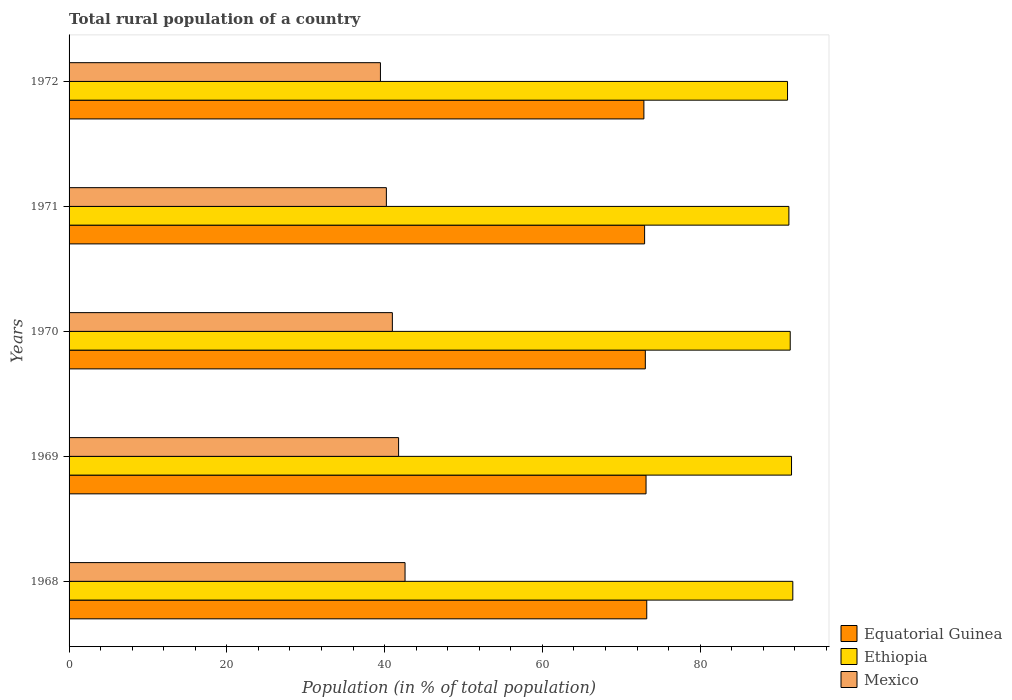How many different coloured bars are there?
Offer a terse response. 3. Are the number of bars per tick equal to the number of legend labels?
Offer a terse response. Yes. How many bars are there on the 2nd tick from the top?
Make the answer very short. 3. What is the label of the 3rd group of bars from the top?
Your answer should be compact. 1970. What is the rural population in Equatorial Guinea in 1969?
Provide a short and direct response. 73.14. Across all years, what is the maximum rural population in Ethiopia?
Make the answer very short. 91.74. Across all years, what is the minimum rural population in Ethiopia?
Ensure brevity in your answer.  91.07. In which year was the rural population in Ethiopia maximum?
Provide a short and direct response. 1968. What is the total rural population in Mexico in the graph?
Offer a very short reply. 205.03. What is the difference between the rural population in Equatorial Guinea in 1970 and that in 1971?
Offer a terse response. 0.09. What is the difference between the rural population in Equatorial Guinea in 1970 and the rural population in Mexico in 1968?
Offer a terse response. 30.46. What is the average rural population in Mexico per year?
Ensure brevity in your answer.  41.01. In the year 1972, what is the difference between the rural population in Equatorial Guinea and rural population in Ethiopia?
Offer a very short reply. -18.21. In how many years, is the rural population in Equatorial Guinea greater than 92 %?
Provide a short and direct response. 0. What is the ratio of the rural population in Mexico in 1969 to that in 1970?
Your answer should be very brief. 1.02. What is the difference between the highest and the second highest rural population in Ethiopia?
Offer a very short reply. 0.16. What is the difference between the highest and the lowest rural population in Equatorial Guinea?
Offer a very short reply. 0.36. What does the 3rd bar from the top in 1971 represents?
Ensure brevity in your answer.  Equatorial Guinea. What does the 3rd bar from the bottom in 1972 represents?
Your answer should be compact. Mexico. Is it the case that in every year, the sum of the rural population in Mexico and rural population in Equatorial Guinea is greater than the rural population in Ethiopia?
Offer a very short reply. Yes. How many bars are there?
Your answer should be very brief. 15. What is the difference between two consecutive major ticks on the X-axis?
Offer a terse response. 20. What is the title of the graph?
Keep it short and to the point. Total rural population of a country. What is the label or title of the X-axis?
Keep it short and to the point. Population (in % of total population). What is the Population (in % of total population) of Equatorial Guinea in 1968?
Your response must be concise. 73.23. What is the Population (in % of total population) of Ethiopia in 1968?
Your answer should be very brief. 91.74. What is the Population (in % of total population) in Mexico in 1968?
Provide a succinct answer. 42.59. What is the Population (in % of total population) in Equatorial Guinea in 1969?
Ensure brevity in your answer.  73.14. What is the Population (in % of total population) of Ethiopia in 1969?
Ensure brevity in your answer.  91.58. What is the Population (in % of total population) of Mexico in 1969?
Give a very brief answer. 41.77. What is the Population (in % of total population) of Equatorial Guinea in 1970?
Give a very brief answer. 73.05. What is the Population (in % of total population) of Ethiopia in 1970?
Make the answer very short. 91.41. What is the Population (in % of total population) of Mexico in 1970?
Offer a terse response. 40.98. What is the Population (in % of total population) in Equatorial Guinea in 1971?
Provide a short and direct response. 72.95. What is the Population (in % of total population) in Ethiopia in 1971?
Offer a terse response. 91.24. What is the Population (in % of total population) of Mexico in 1971?
Offer a very short reply. 40.22. What is the Population (in % of total population) of Equatorial Guinea in 1972?
Ensure brevity in your answer.  72.86. What is the Population (in % of total population) in Ethiopia in 1972?
Offer a terse response. 91.07. What is the Population (in % of total population) of Mexico in 1972?
Make the answer very short. 39.47. Across all years, what is the maximum Population (in % of total population) of Equatorial Guinea?
Ensure brevity in your answer.  73.23. Across all years, what is the maximum Population (in % of total population) of Ethiopia?
Make the answer very short. 91.74. Across all years, what is the maximum Population (in % of total population) in Mexico?
Offer a terse response. 42.59. Across all years, what is the minimum Population (in % of total population) in Equatorial Guinea?
Offer a very short reply. 72.86. Across all years, what is the minimum Population (in % of total population) of Ethiopia?
Your response must be concise. 91.07. Across all years, what is the minimum Population (in % of total population) of Mexico?
Provide a short and direct response. 39.47. What is the total Population (in % of total population) in Equatorial Guinea in the graph?
Offer a very short reply. 365.23. What is the total Population (in % of total population) of Ethiopia in the graph?
Provide a succinct answer. 457.05. What is the total Population (in % of total population) in Mexico in the graph?
Offer a terse response. 205.03. What is the difference between the Population (in % of total population) of Equatorial Guinea in 1968 and that in 1969?
Your response must be concise. 0.09. What is the difference between the Population (in % of total population) in Ethiopia in 1968 and that in 1969?
Your answer should be compact. 0.16. What is the difference between the Population (in % of total population) in Mexico in 1968 and that in 1969?
Your answer should be compact. 0.82. What is the difference between the Population (in % of total population) in Equatorial Guinea in 1968 and that in 1970?
Provide a short and direct response. 0.18. What is the difference between the Population (in % of total population) in Ethiopia in 1968 and that in 1970?
Offer a very short reply. 0.33. What is the difference between the Population (in % of total population) in Mexico in 1968 and that in 1970?
Ensure brevity in your answer.  1.61. What is the difference between the Population (in % of total population) in Equatorial Guinea in 1968 and that in 1971?
Provide a short and direct response. 0.27. What is the difference between the Population (in % of total population) in Ethiopia in 1968 and that in 1971?
Your answer should be compact. 0.5. What is the difference between the Population (in % of total population) in Mexico in 1968 and that in 1971?
Make the answer very short. 2.37. What is the difference between the Population (in % of total population) in Equatorial Guinea in 1968 and that in 1972?
Keep it short and to the point. 0.36. What is the difference between the Population (in % of total population) of Ethiopia in 1968 and that in 1972?
Ensure brevity in your answer.  0.67. What is the difference between the Population (in % of total population) of Mexico in 1968 and that in 1972?
Provide a succinct answer. 3.12. What is the difference between the Population (in % of total population) of Equatorial Guinea in 1969 and that in 1970?
Offer a terse response. 0.09. What is the difference between the Population (in % of total population) of Ethiopia in 1969 and that in 1970?
Ensure brevity in your answer.  0.17. What is the difference between the Population (in % of total population) of Mexico in 1969 and that in 1970?
Ensure brevity in your answer.  0.79. What is the difference between the Population (in % of total population) in Equatorial Guinea in 1969 and that in 1971?
Ensure brevity in your answer.  0.18. What is the difference between the Population (in % of total population) of Ethiopia in 1969 and that in 1971?
Keep it short and to the point. 0.33. What is the difference between the Population (in % of total population) in Mexico in 1969 and that in 1971?
Offer a very short reply. 1.55. What is the difference between the Population (in % of total population) of Equatorial Guinea in 1969 and that in 1972?
Make the answer very short. 0.27. What is the difference between the Population (in % of total population) of Ethiopia in 1969 and that in 1972?
Provide a short and direct response. 0.51. What is the difference between the Population (in % of total population) of Mexico in 1969 and that in 1972?
Ensure brevity in your answer.  2.3. What is the difference between the Population (in % of total population) in Equatorial Guinea in 1970 and that in 1971?
Keep it short and to the point. 0.09. What is the difference between the Population (in % of total population) of Ethiopia in 1970 and that in 1971?
Ensure brevity in your answer.  0.17. What is the difference between the Population (in % of total population) of Mexico in 1970 and that in 1971?
Ensure brevity in your answer.  0.76. What is the difference between the Population (in % of total population) in Equatorial Guinea in 1970 and that in 1972?
Ensure brevity in your answer.  0.18. What is the difference between the Population (in % of total population) in Ethiopia in 1970 and that in 1972?
Offer a terse response. 0.34. What is the difference between the Population (in % of total population) in Mexico in 1970 and that in 1972?
Your answer should be compact. 1.51. What is the difference between the Population (in % of total population) of Equatorial Guinea in 1971 and that in 1972?
Provide a succinct answer. 0.09. What is the difference between the Population (in % of total population) of Ethiopia in 1971 and that in 1972?
Provide a succinct answer. 0.17. What is the difference between the Population (in % of total population) in Mexico in 1971 and that in 1972?
Give a very brief answer. 0.75. What is the difference between the Population (in % of total population) in Equatorial Guinea in 1968 and the Population (in % of total population) in Ethiopia in 1969?
Provide a short and direct response. -18.35. What is the difference between the Population (in % of total population) of Equatorial Guinea in 1968 and the Population (in % of total population) of Mexico in 1969?
Offer a very short reply. 31.46. What is the difference between the Population (in % of total population) in Ethiopia in 1968 and the Population (in % of total population) in Mexico in 1969?
Ensure brevity in your answer.  49.97. What is the difference between the Population (in % of total population) of Equatorial Guinea in 1968 and the Population (in % of total population) of Ethiopia in 1970?
Give a very brief answer. -18.18. What is the difference between the Population (in % of total population) of Equatorial Guinea in 1968 and the Population (in % of total population) of Mexico in 1970?
Your response must be concise. 32.25. What is the difference between the Population (in % of total population) of Ethiopia in 1968 and the Population (in % of total population) of Mexico in 1970?
Provide a succinct answer. 50.76. What is the difference between the Population (in % of total population) in Equatorial Guinea in 1968 and the Population (in % of total population) in Ethiopia in 1971?
Ensure brevity in your answer.  -18.02. What is the difference between the Population (in % of total population) in Equatorial Guinea in 1968 and the Population (in % of total population) in Mexico in 1971?
Make the answer very short. 33.01. What is the difference between the Population (in % of total population) in Ethiopia in 1968 and the Population (in % of total population) in Mexico in 1971?
Your answer should be very brief. 51.52. What is the difference between the Population (in % of total population) in Equatorial Guinea in 1968 and the Population (in % of total population) in Ethiopia in 1972?
Provide a short and direct response. -17.84. What is the difference between the Population (in % of total population) of Equatorial Guinea in 1968 and the Population (in % of total population) of Mexico in 1972?
Your answer should be very brief. 33.76. What is the difference between the Population (in % of total population) in Ethiopia in 1968 and the Population (in % of total population) in Mexico in 1972?
Your answer should be compact. 52.27. What is the difference between the Population (in % of total population) of Equatorial Guinea in 1969 and the Population (in % of total population) of Ethiopia in 1970?
Provide a succinct answer. -18.27. What is the difference between the Population (in % of total population) of Equatorial Guinea in 1969 and the Population (in % of total population) of Mexico in 1970?
Offer a terse response. 32.16. What is the difference between the Population (in % of total population) of Ethiopia in 1969 and the Population (in % of total population) of Mexico in 1970?
Provide a succinct answer. 50.6. What is the difference between the Population (in % of total population) of Equatorial Guinea in 1969 and the Population (in % of total population) of Ethiopia in 1971?
Provide a succinct answer. -18.11. What is the difference between the Population (in % of total population) in Equatorial Guinea in 1969 and the Population (in % of total population) in Mexico in 1971?
Make the answer very short. 32.92. What is the difference between the Population (in % of total population) of Ethiopia in 1969 and the Population (in % of total population) of Mexico in 1971?
Keep it short and to the point. 51.36. What is the difference between the Population (in % of total population) in Equatorial Guinea in 1969 and the Population (in % of total population) in Ethiopia in 1972?
Give a very brief answer. -17.93. What is the difference between the Population (in % of total population) of Equatorial Guinea in 1969 and the Population (in % of total population) of Mexico in 1972?
Make the answer very short. 33.67. What is the difference between the Population (in % of total population) in Ethiopia in 1969 and the Population (in % of total population) in Mexico in 1972?
Provide a short and direct response. 52.11. What is the difference between the Population (in % of total population) in Equatorial Guinea in 1970 and the Population (in % of total population) in Ethiopia in 1971?
Offer a very short reply. -18.2. What is the difference between the Population (in % of total population) in Equatorial Guinea in 1970 and the Population (in % of total population) in Mexico in 1971?
Your answer should be very brief. 32.83. What is the difference between the Population (in % of total population) of Ethiopia in 1970 and the Population (in % of total population) of Mexico in 1971?
Give a very brief answer. 51.19. What is the difference between the Population (in % of total population) of Equatorial Guinea in 1970 and the Population (in % of total population) of Ethiopia in 1972?
Give a very brief answer. -18.03. What is the difference between the Population (in % of total population) of Equatorial Guinea in 1970 and the Population (in % of total population) of Mexico in 1972?
Provide a short and direct response. 33.58. What is the difference between the Population (in % of total population) in Ethiopia in 1970 and the Population (in % of total population) in Mexico in 1972?
Provide a short and direct response. 51.94. What is the difference between the Population (in % of total population) in Equatorial Guinea in 1971 and the Population (in % of total population) in Ethiopia in 1972?
Your response must be concise. -18.12. What is the difference between the Population (in % of total population) in Equatorial Guinea in 1971 and the Population (in % of total population) in Mexico in 1972?
Your response must be concise. 33.49. What is the difference between the Population (in % of total population) in Ethiopia in 1971 and the Population (in % of total population) in Mexico in 1972?
Your answer should be compact. 51.78. What is the average Population (in % of total population) of Equatorial Guinea per year?
Offer a terse response. 73.05. What is the average Population (in % of total population) in Ethiopia per year?
Provide a succinct answer. 91.41. What is the average Population (in % of total population) in Mexico per year?
Make the answer very short. 41.01. In the year 1968, what is the difference between the Population (in % of total population) in Equatorial Guinea and Population (in % of total population) in Ethiopia?
Provide a short and direct response. -18.51. In the year 1968, what is the difference between the Population (in % of total population) of Equatorial Guinea and Population (in % of total population) of Mexico?
Your answer should be compact. 30.64. In the year 1968, what is the difference between the Population (in % of total population) of Ethiopia and Population (in % of total population) of Mexico?
Your answer should be compact. 49.15. In the year 1969, what is the difference between the Population (in % of total population) of Equatorial Guinea and Population (in % of total population) of Ethiopia?
Give a very brief answer. -18.44. In the year 1969, what is the difference between the Population (in % of total population) in Equatorial Guinea and Population (in % of total population) in Mexico?
Your answer should be compact. 31.37. In the year 1969, what is the difference between the Population (in % of total population) of Ethiopia and Population (in % of total population) of Mexico?
Offer a very short reply. 49.81. In the year 1970, what is the difference between the Population (in % of total population) in Equatorial Guinea and Population (in % of total population) in Ethiopia?
Your response must be concise. -18.37. In the year 1970, what is the difference between the Population (in % of total population) of Equatorial Guinea and Population (in % of total population) of Mexico?
Provide a short and direct response. 32.07. In the year 1970, what is the difference between the Population (in % of total population) of Ethiopia and Population (in % of total population) of Mexico?
Your answer should be very brief. 50.43. In the year 1971, what is the difference between the Population (in % of total population) of Equatorial Guinea and Population (in % of total population) of Ethiopia?
Your answer should be very brief. -18.29. In the year 1971, what is the difference between the Population (in % of total population) of Equatorial Guinea and Population (in % of total population) of Mexico?
Provide a short and direct response. 32.73. In the year 1971, what is the difference between the Population (in % of total population) in Ethiopia and Population (in % of total population) in Mexico?
Offer a terse response. 51.02. In the year 1972, what is the difference between the Population (in % of total population) of Equatorial Guinea and Population (in % of total population) of Ethiopia?
Your answer should be compact. -18.21. In the year 1972, what is the difference between the Population (in % of total population) of Equatorial Guinea and Population (in % of total population) of Mexico?
Your answer should be compact. 33.4. In the year 1972, what is the difference between the Population (in % of total population) in Ethiopia and Population (in % of total population) in Mexico?
Provide a succinct answer. 51.6. What is the ratio of the Population (in % of total population) of Mexico in 1968 to that in 1969?
Provide a succinct answer. 1.02. What is the ratio of the Population (in % of total population) in Equatorial Guinea in 1968 to that in 1970?
Make the answer very short. 1. What is the ratio of the Population (in % of total population) in Ethiopia in 1968 to that in 1970?
Make the answer very short. 1. What is the ratio of the Population (in % of total population) of Mexico in 1968 to that in 1970?
Your response must be concise. 1.04. What is the ratio of the Population (in % of total population) in Ethiopia in 1968 to that in 1971?
Make the answer very short. 1.01. What is the ratio of the Population (in % of total population) of Mexico in 1968 to that in 1971?
Give a very brief answer. 1.06. What is the ratio of the Population (in % of total population) of Ethiopia in 1968 to that in 1972?
Keep it short and to the point. 1.01. What is the ratio of the Population (in % of total population) of Mexico in 1968 to that in 1972?
Make the answer very short. 1.08. What is the ratio of the Population (in % of total population) of Mexico in 1969 to that in 1970?
Make the answer very short. 1.02. What is the ratio of the Population (in % of total population) of Mexico in 1969 to that in 1971?
Your answer should be very brief. 1.04. What is the ratio of the Population (in % of total population) in Ethiopia in 1969 to that in 1972?
Ensure brevity in your answer.  1.01. What is the ratio of the Population (in % of total population) in Mexico in 1969 to that in 1972?
Give a very brief answer. 1.06. What is the ratio of the Population (in % of total population) of Equatorial Guinea in 1970 to that in 1971?
Offer a very short reply. 1. What is the ratio of the Population (in % of total population) of Ethiopia in 1970 to that in 1971?
Ensure brevity in your answer.  1. What is the ratio of the Population (in % of total population) in Mexico in 1970 to that in 1971?
Offer a very short reply. 1.02. What is the ratio of the Population (in % of total population) of Equatorial Guinea in 1970 to that in 1972?
Offer a terse response. 1. What is the ratio of the Population (in % of total population) of Mexico in 1970 to that in 1972?
Offer a terse response. 1.04. What is the ratio of the Population (in % of total population) in Ethiopia in 1971 to that in 1972?
Offer a terse response. 1. What is the ratio of the Population (in % of total population) of Mexico in 1971 to that in 1972?
Make the answer very short. 1.02. What is the difference between the highest and the second highest Population (in % of total population) of Equatorial Guinea?
Keep it short and to the point. 0.09. What is the difference between the highest and the second highest Population (in % of total population) of Ethiopia?
Offer a very short reply. 0.16. What is the difference between the highest and the second highest Population (in % of total population) of Mexico?
Provide a succinct answer. 0.82. What is the difference between the highest and the lowest Population (in % of total population) of Equatorial Guinea?
Offer a terse response. 0.36. What is the difference between the highest and the lowest Population (in % of total population) of Ethiopia?
Your response must be concise. 0.67. What is the difference between the highest and the lowest Population (in % of total population) of Mexico?
Make the answer very short. 3.12. 